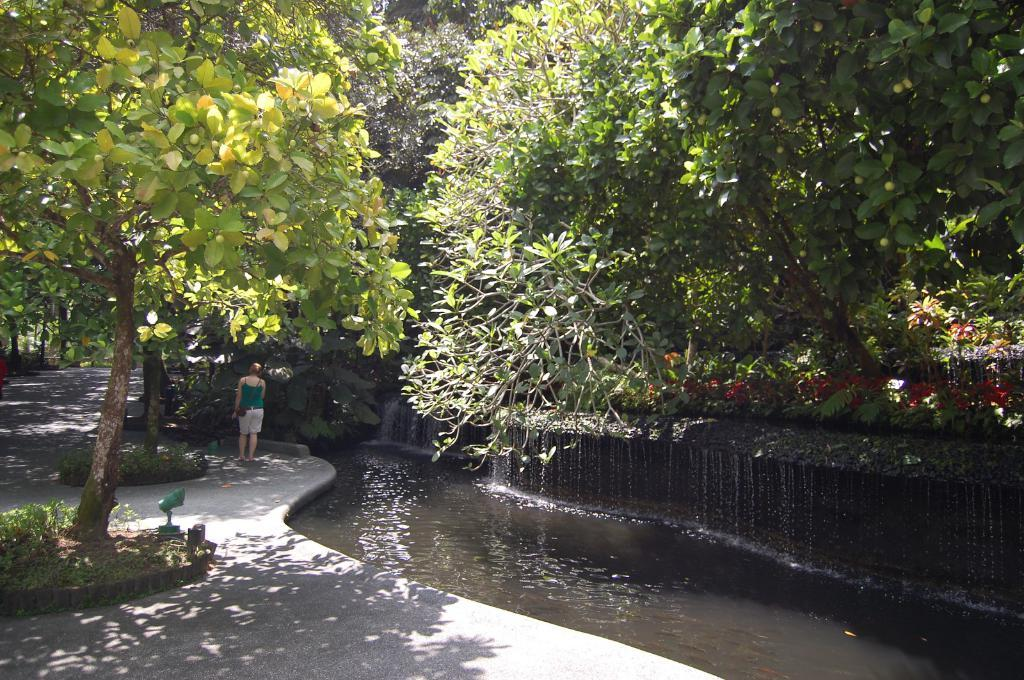What is located on the right side of the image? There is water on the right side of the image. What can be seen in the middle of the image? There is a person standing on the road. What type of vegetation is present on both sides of the image? Trees are present on both sides of the image. Where is the lunchroom located in the image? There is no lunchroom present in the image. How many sheep can be seen grazing on the road in the image? There are no sheep present in the image. 